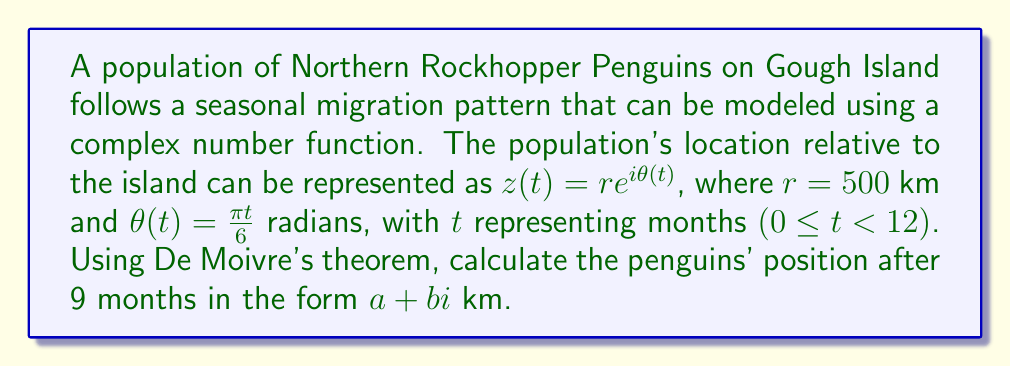Can you solve this math problem? Let's approach this step-by-step:

1) We are given $z(t) = re^{i\theta(t)}$, where $r = 500$ km and $\theta(t) = \frac{\pi t}{6}$ radians.

2) For $t = 9$ months, we need to calculate:

   $z(9) = 500e^{i\frac{\pi 9}{6}}$

3) Using De Moivre's theorem, we know that:

   $e^{i\theta} = \cos\theta + i\sin\theta$

4) Therefore:

   $z(9) = 500(\cos(\frac{3\pi}{2}) + i\sin(\frac{3\pi}{2}))$

5) We know that $\cos(\frac{3\pi}{2}) = 0$ and $\sin(\frac{3\pi}{2}) = -1$

6) Substituting these values:

   $z(9) = 500(0 - i)$

7) Simplifying:

   $z(9) = -500i$ km

8) In the form $a + bi$ km, this is:

   $z(9) = 0 - 500i$ km
Answer: $0 - 500i$ km 